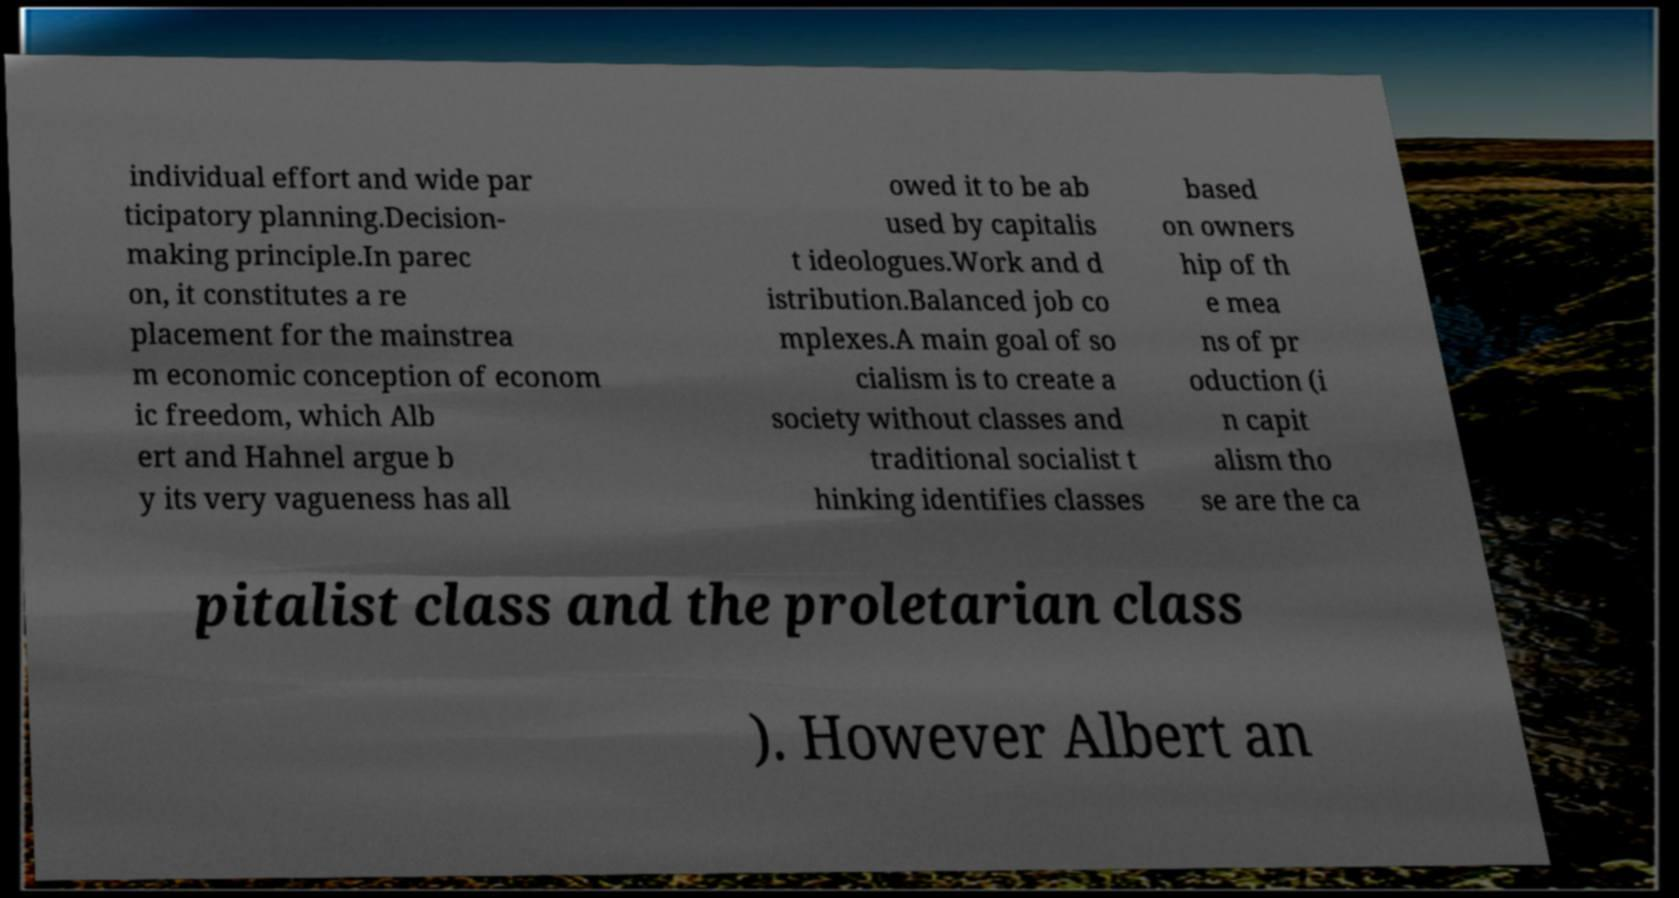For documentation purposes, I need the text within this image transcribed. Could you provide that? individual effort and wide par ticipatory planning.Decision- making principle.In parec on, it constitutes a re placement for the mainstrea m economic conception of econom ic freedom, which Alb ert and Hahnel argue b y its very vagueness has all owed it to be ab used by capitalis t ideologues.Work and d istribution.Balanced job co mplexes.A main goal of so cialism is to create a society without classes and traditional socialist t hinking identifies classes based on owners hip of th e mea ns of pr oduction (i n capit alism tho se are the ca pitalist class and the proletarian class ). However Albert an 